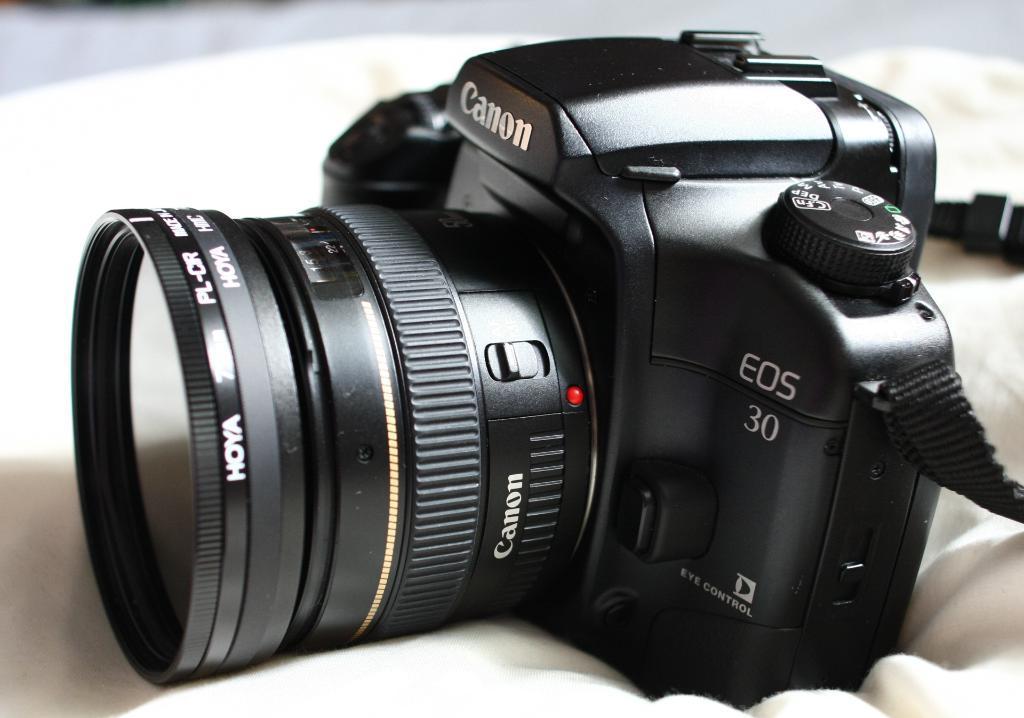Describe this image in one or two sentences. In this picture there is a black camera. At the bottom there is a white cloth. 